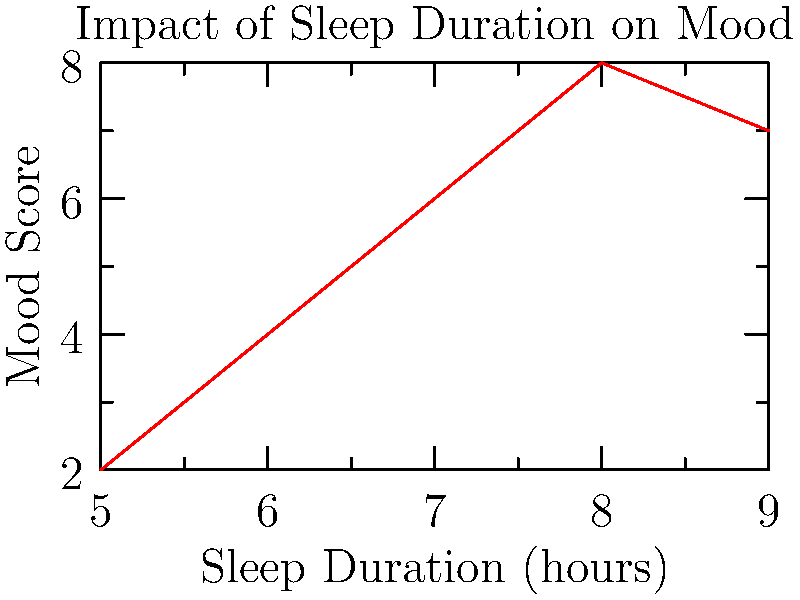Based on the line graph showing the relationship between sleep duration and mood score, at which sleep duration does the child's mood score peak? To answer this question, we need to analyze the line graph carefully:

1. The x-axis represents sleep duration in hours, ranging from 5 to 9 hours.
2. The y-axis represents the mood score, with higher scores indicating better mood.
3. We need to find the highest point on the graph, which corresponds to the peak mood score.

Examining the graph:
- At 5 hours of sleep, the mood score is low (about 2).
- The mood score increases as sleep duration increases from 5 to 8 hours.
- The highest point on the graph occurs at 8 hours of sleep, with a mood score of 8.
- After 8 hours, the mood score slightly decreases for 9 hours of sleep.

Therefore, the child's mood score peaks at 8 hours of sleep.

This information is valuable for parents interested in improving their child's mental health, as it demonstrates the importance of ensuring adequate sleep duration for optimal mood.
Answer: 8 hours 